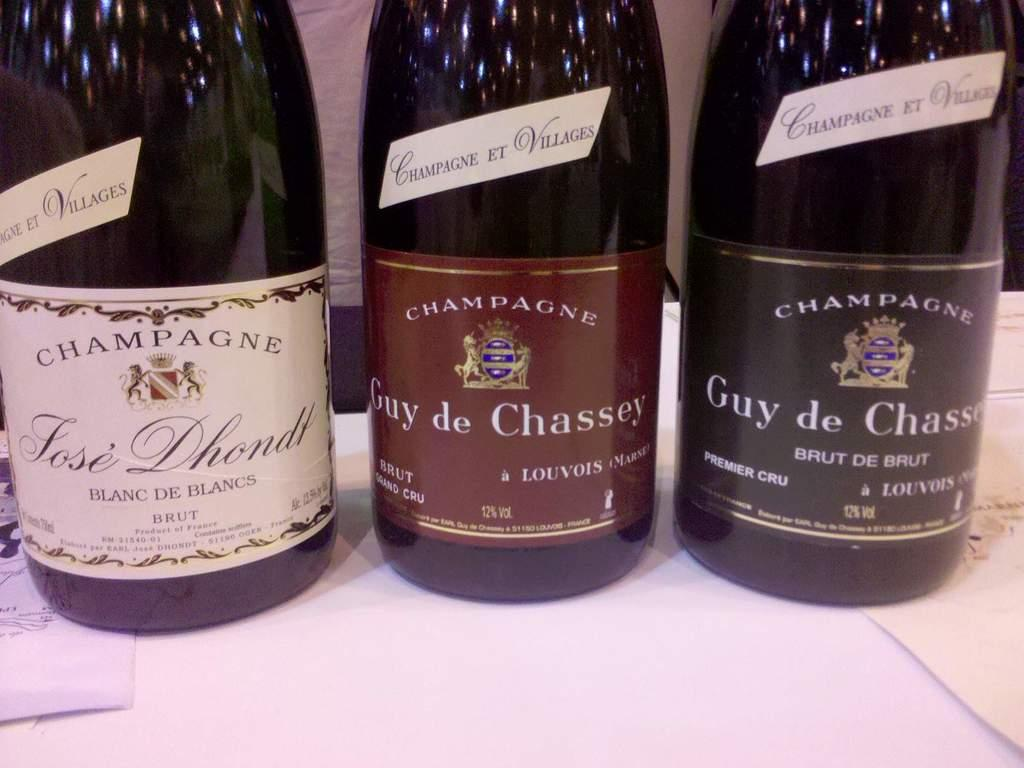<image>
Offer a succinct explanation of the picture presented. Three bottles of champagne stand next to each other. 